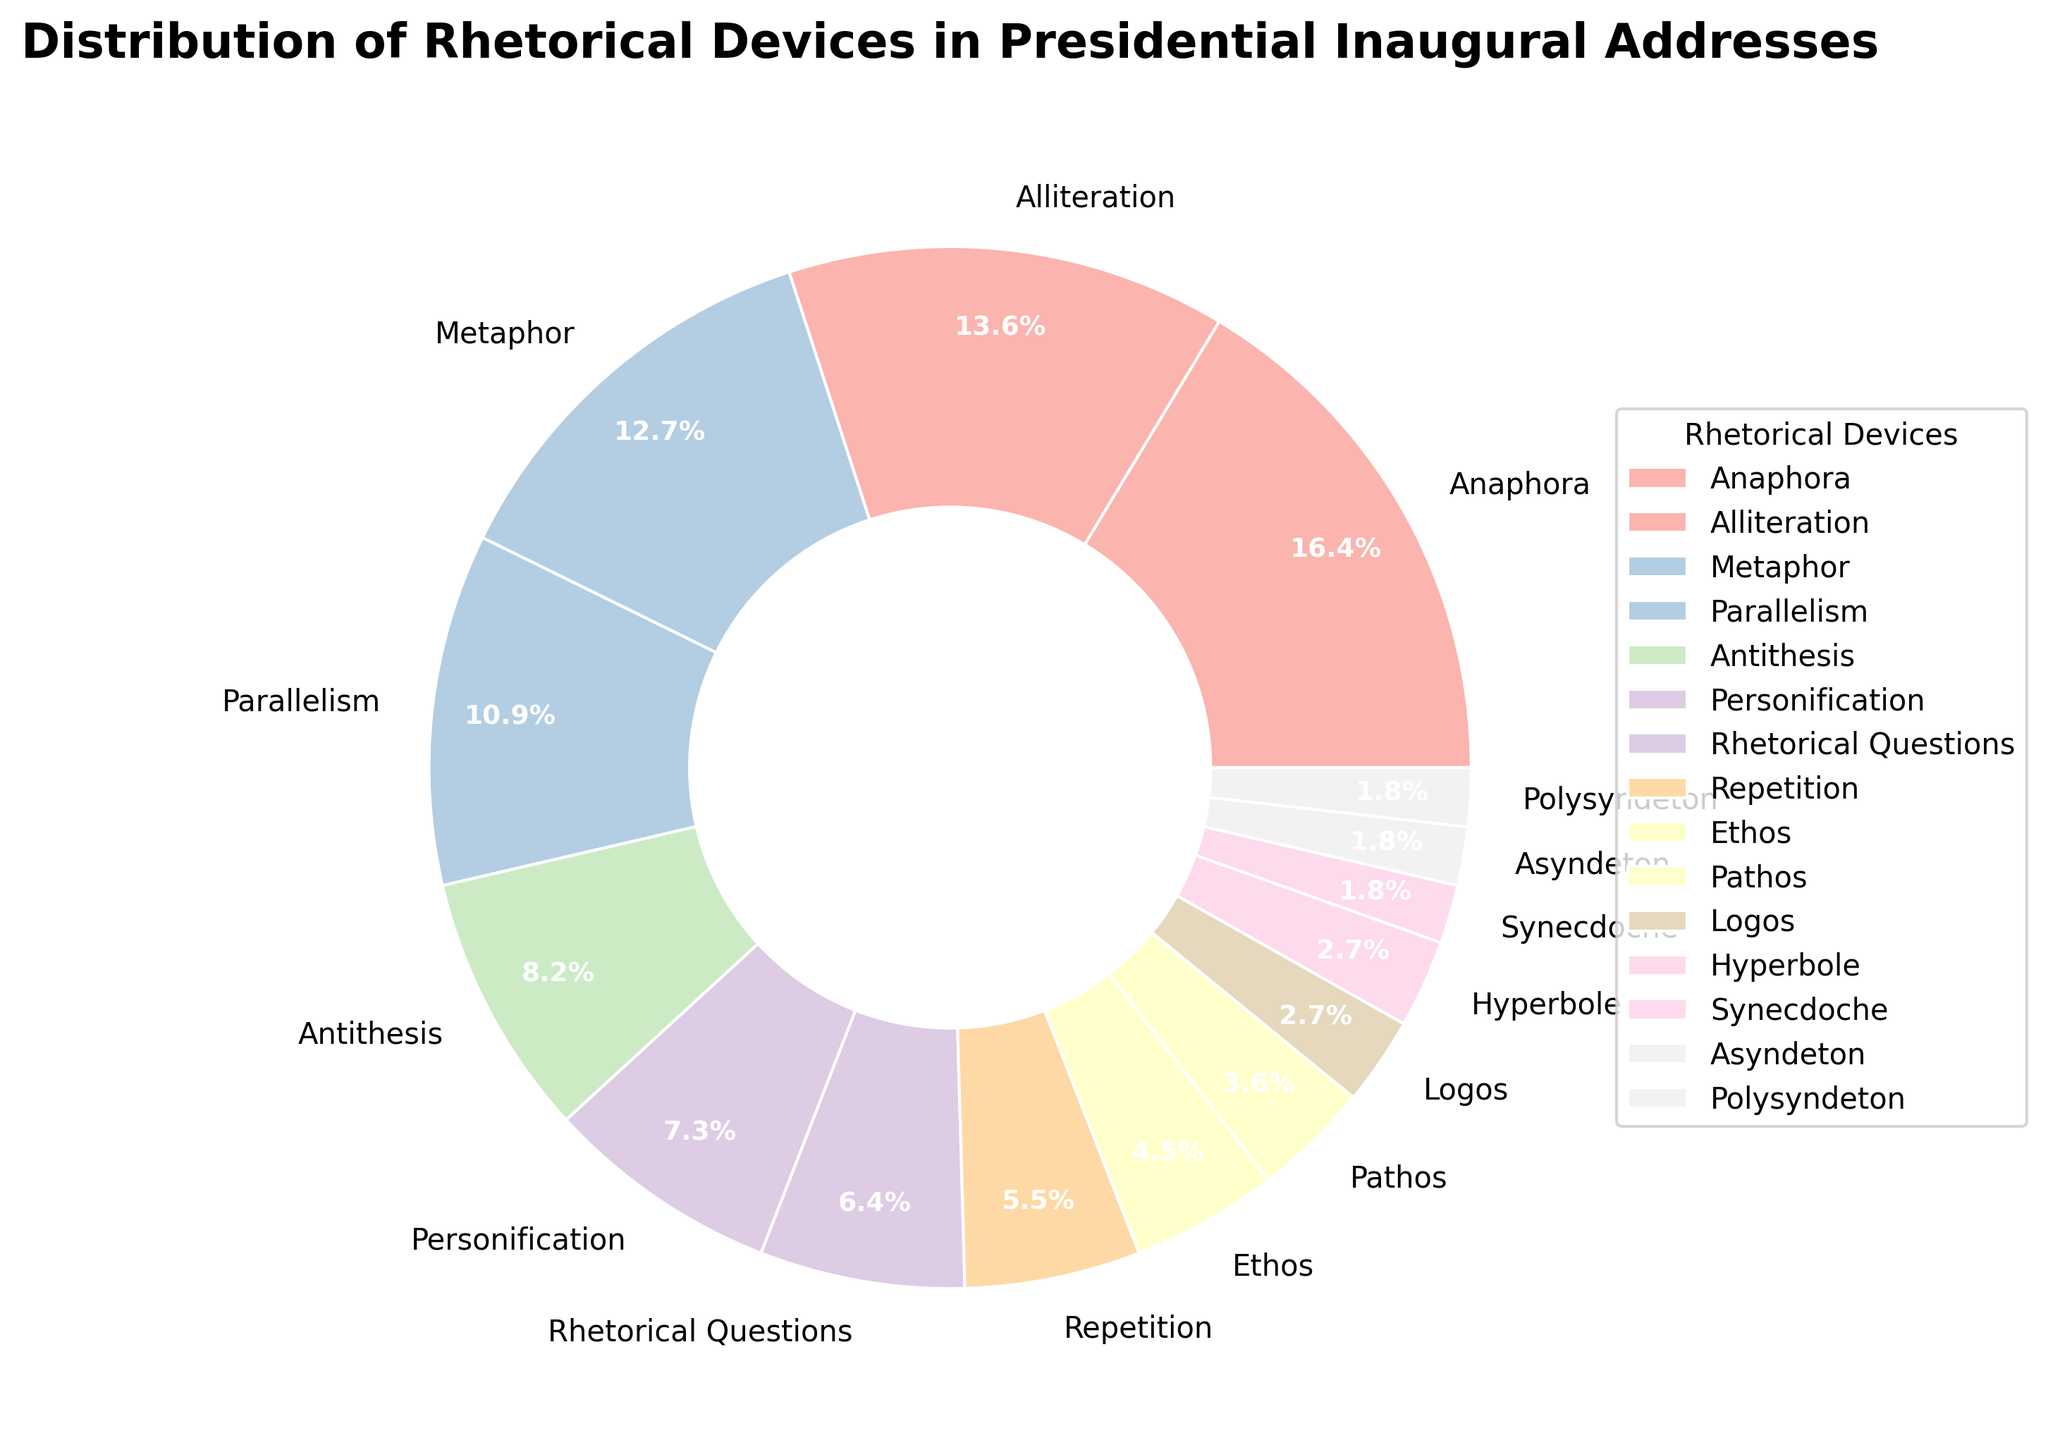What are the top three most frequently used rhetorical devices in presidential inaugural addresses? The top three most frequently used rhetorical devices can be identified by looking at the slices of the pie chart with the largest percentages. They are Anaphora (18%), Alliteration (15%), and Metaphor (14%).
Answer: Anaphora, Alliteration, Metaphor Which rhetorical device is more commonly used: Antithesis or Personification? To find out which is more commonly used between Antithesis and Personification, we compare their percentages in the pie chart. Antithesis has 9% while Personification has 8%, meaning Antithesis is more commonly used.
Answer: Antithesis What is the combined percentage of Ethos, Pathos, and Logos used in the addresses? To calculate the combined percentage, we sum the individual percentages of Ethos (5%), Pathos (4%), and Logos (3%). Therefore, 5% + 4% + 3% = 12%.
Answer: 12% Which rhetorical device has an equal percentage to Hyperbole in the distribution? We need to identify the rhetorical device that shares the same percentage as Hyperbole, which is 3%. Logos also has a percentage of 3%.
Answer: Logos Is the usage of Anaphora greater than the combined usage of Rhetorical Questions and Repetition? First, we sum the percentages of Rhetorical Questions (7%) and Repetition (6%), which equals 13%. Then we compare this to Anaphora's 18%. Since 18% is greater than 13%, Anaphora's usage is indeed greater.
Answer: Yes How much more frequently is Alliteration used compared to Polysyndeton? We subtract the percentage of Polysyndeton (2%) from Alliteration (15%) to find the difference: 15% - 2% = 13%.
Answer: 13% What percentage less is the usage of Pathos than Parallelism? We subtract the percentage of Pathos (4%) from Parallelism (12%) to find the difference: 12% - 4% = 8%.
Answer: 8% Which device has the smallest usage percentage in presidential inaugural addresses? The smallest slices in the pie chart represent Synecdoche, Asyndeton, and Polysyndeton, each with 2%.
Answer: Synecdoche, Asyndeton, Polysyndeton What is the total percentage of devices used less frequently than Metaphor? We sum the percentages of each device that has a smaller percentage than Metaphor (14%): Parallelism (12%), Antithesis (9%), Personification (8%), Rhetorical Questions (7%), Repetition (6%), Ethos (5%), Pathos (4%), Logos (3%), Hyperbole (3%), Synecdoche (2%), Asyndeton (2%), and Polysyndeton (2%). This totals to 63%.
Answer: 63% 